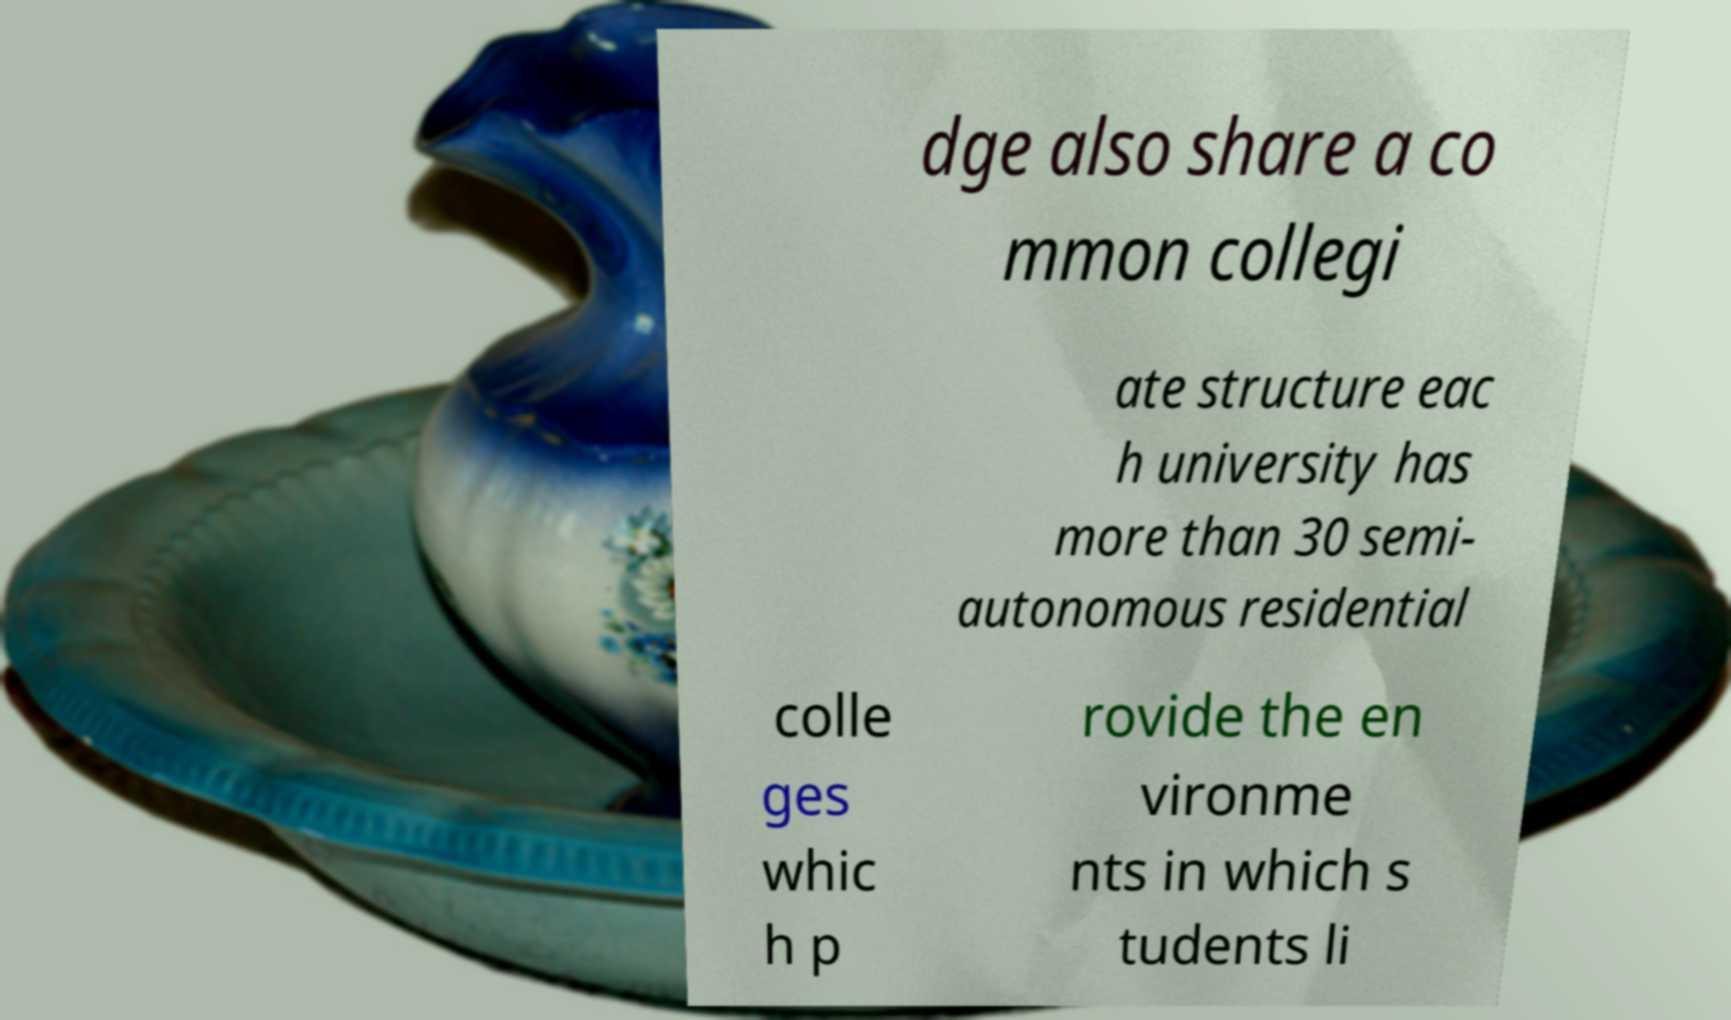Please identify and transcribe the text found in this image. dge also share a co mmon collegi ate structure eac h university has more than 30 semi- autonomous residential colle ges whic h p rovide the en vironme nts in which s tudents li 